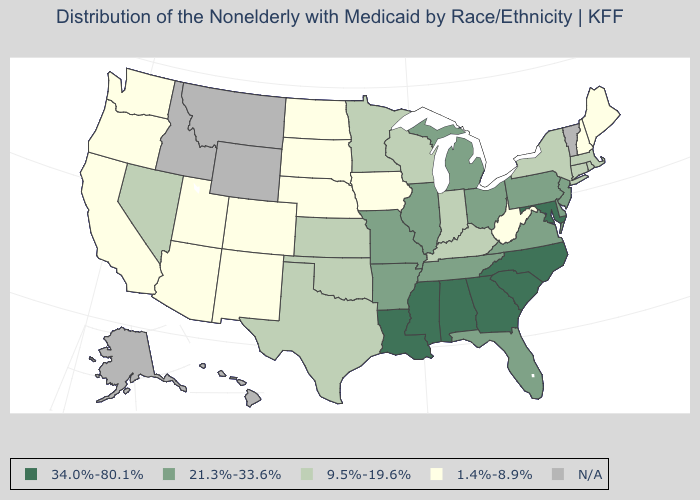What is the value of Ohio?
Quick response, please. 21.3%-33.6%. What is the value of Missouri?
Be succinct. 21.3%-33.6%. Which states have the highest value in the USA?
Answer briefly. Alabama, Georgia, Louisiana, Maryland, Mississippi, North Carolina, South Carolina. What is the value of South Dakota?
Short answer required. 1.4%-8.9%. What is the lowest value in the South?
Be succinct. 1.4%-8.9%. Name the states that have a value in the range 9.5%-19.6%?
Quick response, please. Connecticut, Indiana, Kansas, Kentucky, Massachusetts, Minnesota, Nevada, New York, Oklahoma, Rhode Island, Texas, Wisconsin. What is the highest value in states that border Nevada?
Concise answer only. 1.4%-8.9%. Is the legend a continuous bar?
Write a very short answer. No. Does Oregon have the lowest value in the USA?
Answer briefly. Yes. Name the states that have a value in the range 1.4%-8.9%?
Concise answer only. Arizona, California, Colorado, Iowa, Maine, Nebraska, New Hampshire, New Mexico, North Dakota, Oregon, South Dakota, Utah, Washington, West Virginia. Name the states that have a value in the range 1.4%-8.9%?
Write a very short answer. Arizona, California, Colorado, Iowa, Maine, Nebraska, New Hampshire, New Mexico, North Dakota, Oregon, South Dakota, Utah, Washington, West Virginia. Which states have the lowest value in the South?
Short answer required. West Virginia. Name the states that have a value in the range 21.3%-33.6%?
Give a very brief answer. Arkansas, Delaware, Florida, Illinois, Michigan, Missouri, New Jersey, Ohio, Pennsylvania, Tennessee, Virginia. Does West Virginia have the lowest value in the USA?
Quick response, please. Yes. 